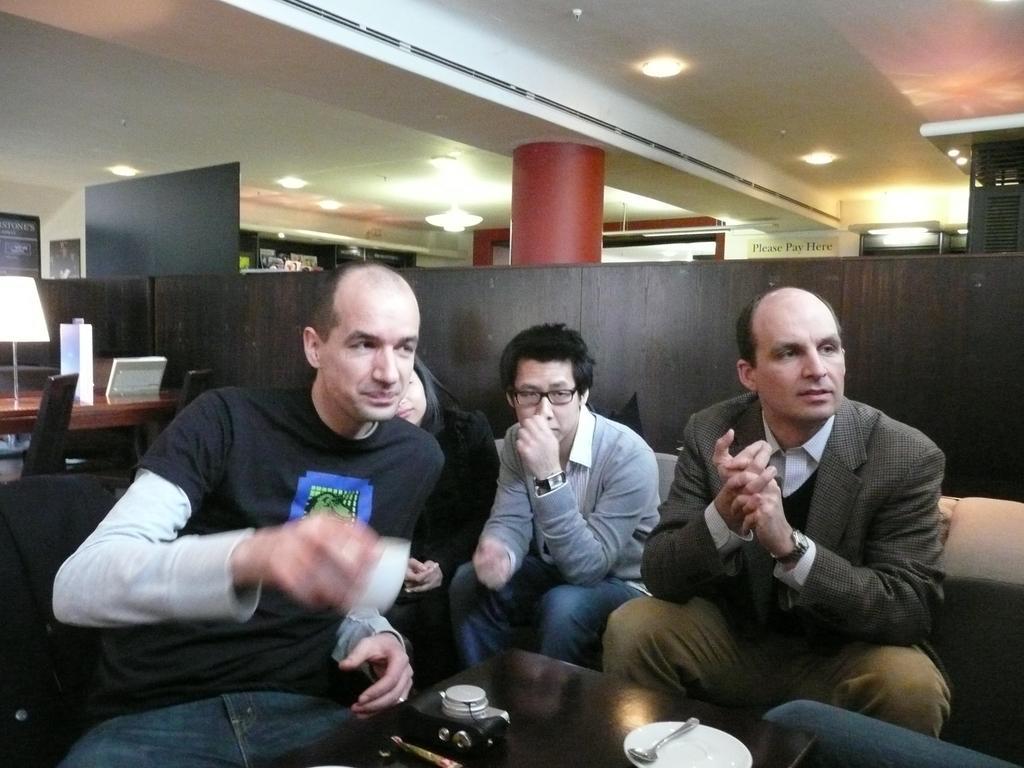Can you describe this image briefly? This 4 persons are sitting on a couch. In-front of this 4 persons there is a table. On a table there is a camera, plate and spoon. This person is holding a cup. On this table there is a lantern lamp. On wall there are different type of posters. Light is attached to a roof top. This is a red piller. 